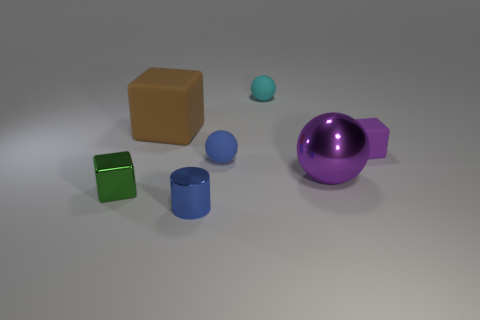Add 2 small matte things. How many objects exist? 9 Subtract all spheres. How many objects are left? 4 Subtract all small green shiny cylinders. Subtract all tiny purple rubber objects. How many objects are left? 6 Add 3 matte objects. How many matte objects are left? 7 Add 1 large metallic balls. How many large metallic balls exist? 2 Subtract 0 brown spheres. How many objects are left? 7 